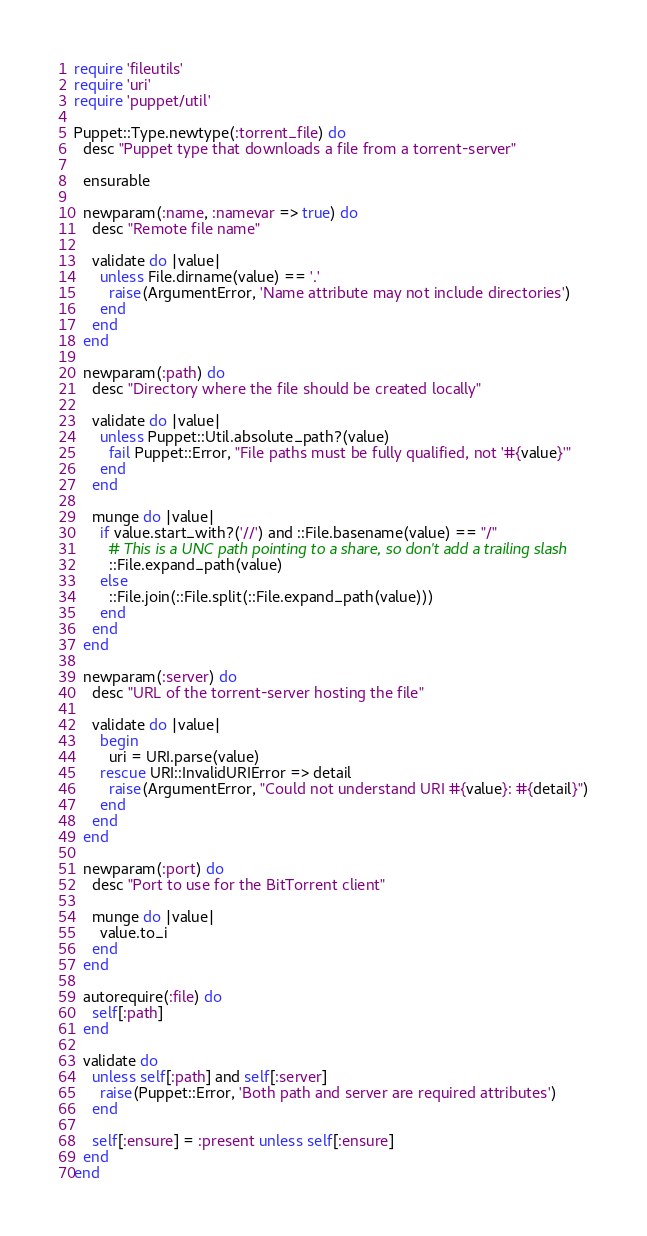Convert code to text. <code><loc_0><loc_0><loc_500><loc_500><_Ruby_>require 'fileutils'
require 'uri'
require 'puppet/util'

Puppet::Type.newtype(:torrent_file) do
  desc "Puppet type that downloads a file from a torrent-server"

  ensurable

  newparam(:name, :namevar => true) do
    desc "Remote file name"

    validate do |value|
      unless File.dirname(value) == '.'
        raise(ArgumentError, 'Name attribute may not include directories')
      end
    end
  end

  newparam(:path) do
    desc "Directory where the file should be created locally"

    validate do |value|
      unless Puppet::Util.absolute_path?(value)
        fail Puppet::Error, "File paths must be fully qualified, not '#{value}'"
      end
    end

    munge do |value|
      if value.start_with?('//') and ::File.basename(value) == "/"
        # This is a UNC path pointing to a share, so don't add a trailing slash
        ::File.expand_path(value)
      else
        ::File.join(::File.split(::File.expand_path(value)))
      end
    end
  end

  newparam(:server) do
    desc "URL of the torrent-server hosting the file"

    validate do |value|
      begin
        uri = URI.parse(value)
      rescue URI::InvalidURIError => detail
        raise(ArgumentError, "Could not understand URI #{value}: #{detail}")
      end
    end
  end

  newparam(:port) do
    desc "Port to use for the BitTorrent client"

    munge do |value|
      value.to_i
    end
  end

  autorequire(:file) do
    self[:path]
  end

  validate do
    unless self[:path] and self[:server]
      raise(Puppet::Error, 'Both path and server are required attributes')
    end

    self[:ensure] = :present unless self[:ensure]
  end
end
</code> 